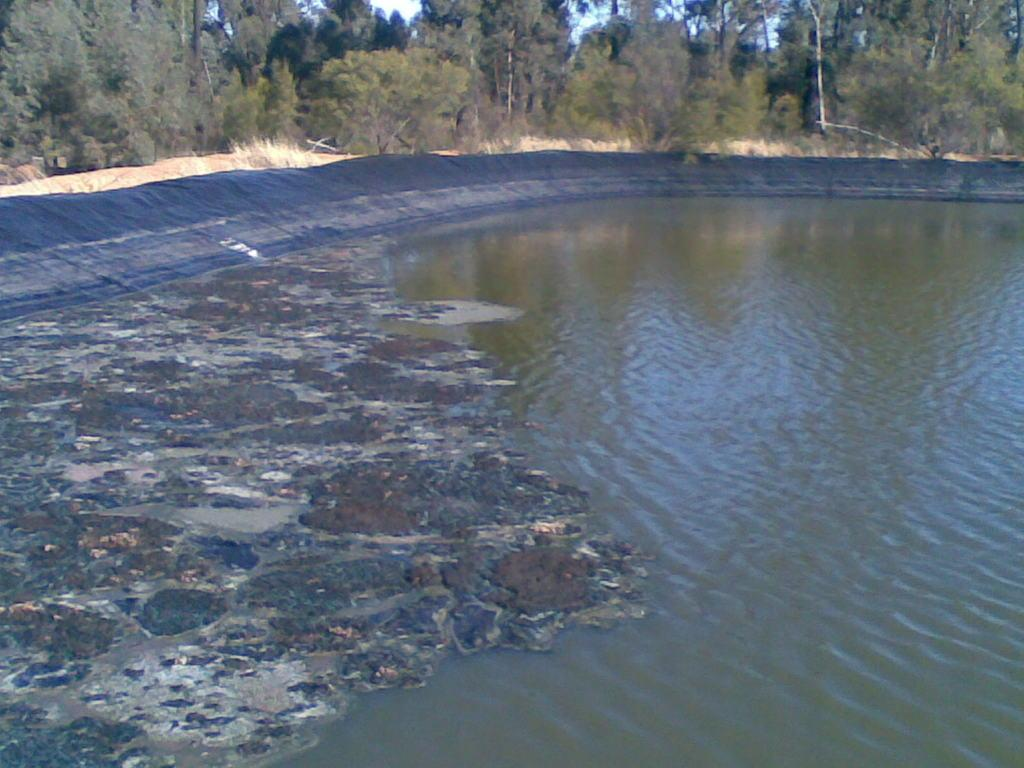What is the primary element visible in the image? There is water in the image. What is covering the water? There is a layer on the water. What can be seen beneath the water? The ground is visible in the image. What type of vegetation is present on the ground? There are trees, grass, and plants visible on the ground. What is visible above the water? The sky is visible in the image. What type of holiday is the father taking with his passenger in the image? There is no reference to a father, passenger, or holiday in the image; it features water with a layer on it and a visible ground, sky, and vegetation. 